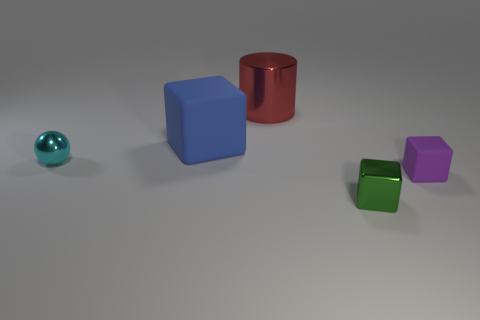What is the shape of the tiny metal thing that is in front of the rubber block that is in front of the cube that is behind the cyan thing?
Your answer should be compact. Cube. What number of things are either metal objects that are in front of the large blue rubber object or things that are in front of the large blue matte object?
Offer a terse response. 3. Do the cyan metal ball and the matte block that is in front of the blue matte thing have the same size?
Keep it short and to the point. Yes. Does the tiny block in front of the tiny rubber block have the same material as the object that is behind the blue matte block?
Provide a short and direct response. Yes. Are there an equal number of large blue objects that are right of the red metallic thing and large red shiny cylinders that are in front of the small purple block?
Your response must be concise. Yes. How many small rubber cubes have the same color as the large metallic cylinder?
Make the answer very short. 0. How many matte objects are large cylinders or large cyan cylinders?
Ensure brevity in your answer.  0. There is a metal thing left of the big metallic object; is its shape the same as the thing that is behind the big blue matte object?
Provide a succinct answer. No. There is a small green object; how many small cyan things are on the left side of it?
Give a very brief answer. 1. Is there a big red block made of the same material as the small green thing?
Offer a terse response. No. 